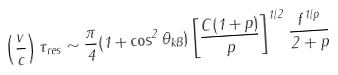Convert formula to latex. <formula><loc_0><loc_0><loc_500><loc_500>\left ( \frac { v } { c } \right ) \tau _ { r e s } \sim \frac { \pi } { 4 } ( 1 + \cos ^ { 2 } \theta _ { k B } ) \left [ \frac { C ( 1 + p ) } { p } \right ] ^ { 1 / 2 } \frac { f ^ { 1 / p } } { 2 + p }</formula> 